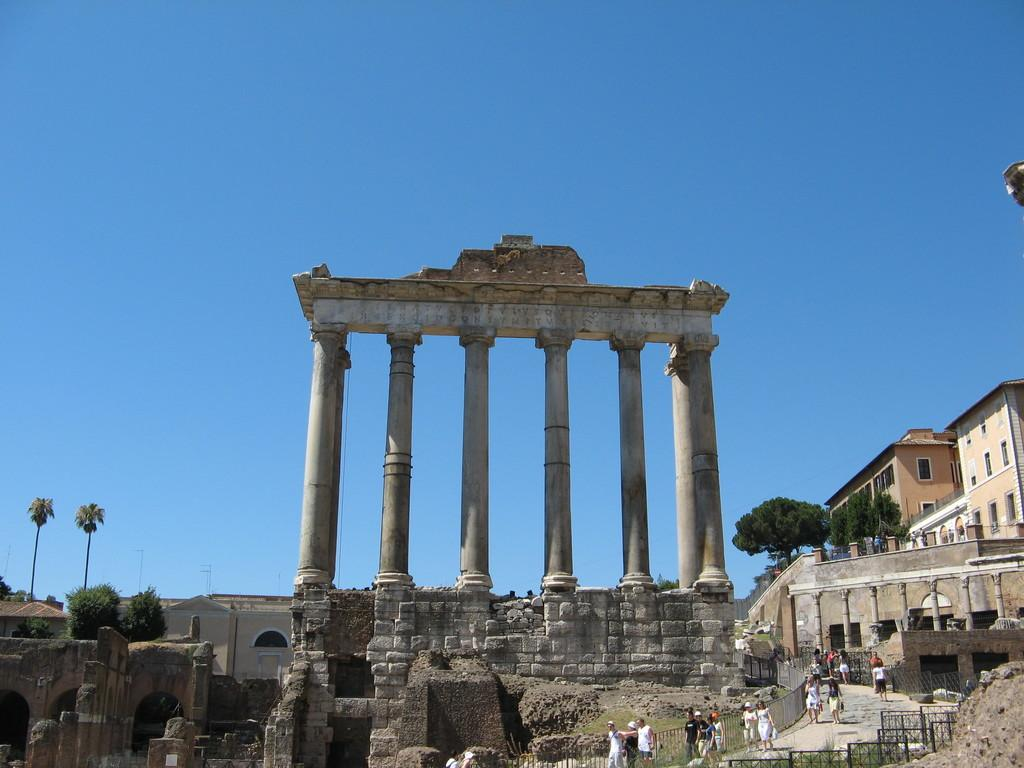What type of structures can be seen in the image? There are buildings in the image. What artistic elements are present in the image? There are sculptures in the image. What safety feature can be seen in the image? There are railings in the image. What are the people in the image doing? There are persons walking on a walking path in the image. What type of vegetation is present in the image? There are trees in the image. What part of the natural environment is visible in the image? The sky is visible in the image. How many goldfish can be seen swimming in the image? There are no goldfish present in the image. What type of animal is grazing on the grass in the image? There are no animals grazing on the grass in the image. 